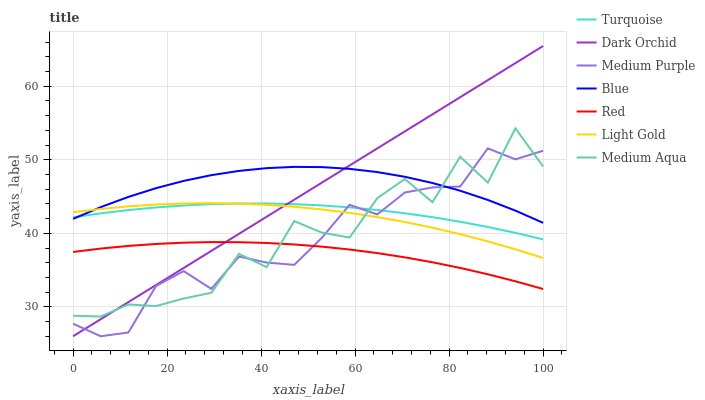Does Red have the minimum area under the curve?
Answer yes or no. Yes. Does Blue have the maximum area under the curve?
Answer yes or no. Yes. Does Turquoise have the minimum area under the curve?
Answer yes or no. No. Does Turquoise have the maximum area under the curve?
Answer yes or no. No. Is Dark Orchid the smoothest?
Answer yes or no. Yes. Is Medium Aqua the roughest?
Answer yes or no. Yes. Is Turquoise the smoothest?
Answer yes or no. No. Is Turquoise the roughest?
Answer yes or no. No. Does Dark Orchid have the lowest value?
Answer yes or no. Yes. Does Turquoise have the lowest value?
Answer yes or no. No. Does Dark Orchid have the highest value?
Answer yes or no. Yes. Does Turquoise have the highest value?
Answer yes or no. No. Is Red less than Light Gold?
Answer yes or no. Yes. Is Light Gold greater than Red?
Answer yes or no. Yes. Does Medium Aqua intersect Light Gold?
Answer yes or no. Yes. Is Medium Aqua less than Light Gold?
Answer yes or no. No. Is Medium Aqua greater than Light Gold?
Answer yes or no. No. Does Red intersect Light Gold?
Answer yes or no. No. 